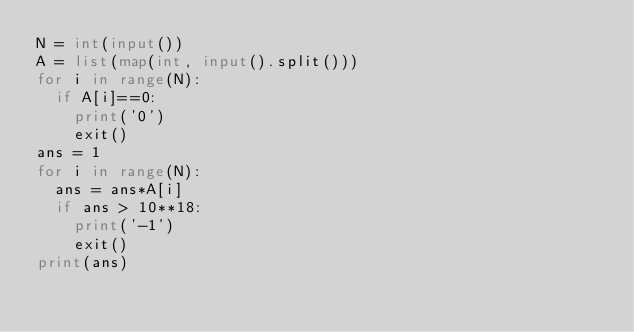<code> <loc_0><loc_0><loc_500><loc_500><_Python_>N = int(input())
A = list(map(int, input().split()))
for i in range(N):
  if A[i]==0:
    print('0')
    exit()
ans = 1
for i in range(N):
  ans = ans*A[i]
  if ans > 10**18:
    print('-1')
    exit()
print(ans)</code> 